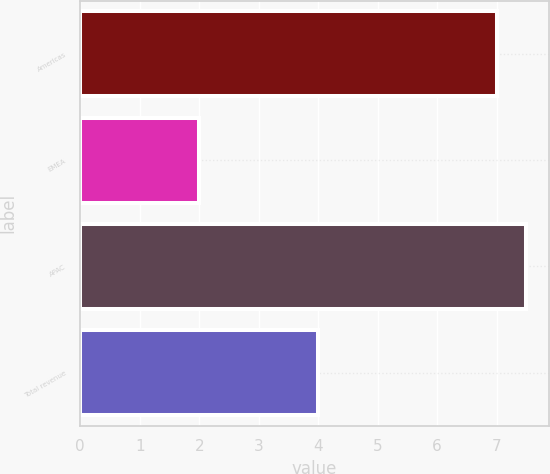<chart> <loc_0><loc_0><loc_500><loc_500><bar_chart><fcel>Americas<fcel>EMEA<fcel>APAC<fcel>Total revenue<nl><fcel>7<fcel>2<fcel>7.5<fcel>4<nl></chart> 